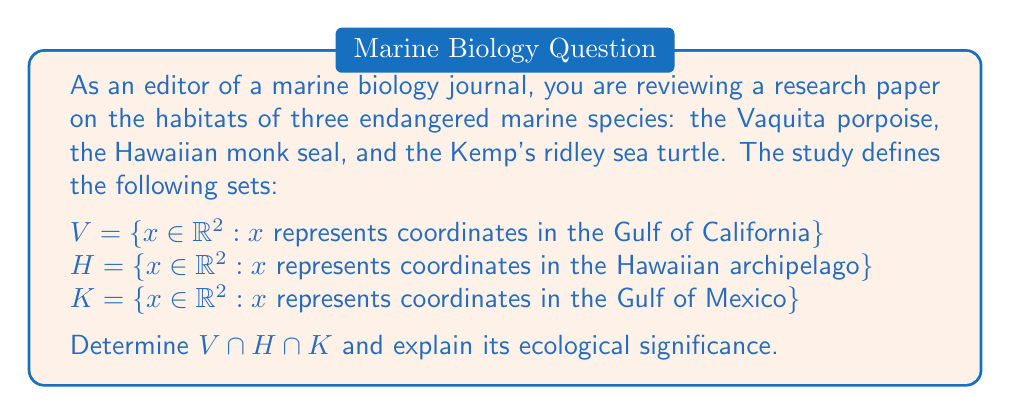Help me with this question. To solve this problem, we need to understand the concept of set intersection and apply it to the given sets representing the habitats of the three marine species.

1. Set intersection:
   The intersection of sets A and B, denoted as $A \cap B$, is the set of all elements that are common to both A and B.

2. For three sets, the intersection is defined as:
   $A \cap B \cap C = \{x : x \in A \text{ and } x \in B \text{ and } x \in C\}$

3. Analyzing the given sets:
   $V$: represents coordinates in the Gulf of California
   $H$: represents coordinates in the Hawaiian archipelago
   $K$: represents coordinates in the Gulf of Mexico

4. Geographical analysis:
   The Gulf of California, Hawaiian archipelago, and Gulf of Mexico are distinct geographical regions that do not overlap.

5. Set intersection:
   $V \cap H \cap K = \emptyset$ (the empty set)

6. Ecological significance:
   The empty intersection indicates that there is no geographical overlap in the habitats of these three endangered marine species. This implies that:
   a) Each species has a unique habitat range.
   b) Conservation efforts must be tailored to each specific location.
   c) There is no single area where protecting all three species simultaneously is possible.
   d) The species are unlikely to interact directly in their natural habitats.
Answer: $V \cap H \cap K = \emptyset$

The empty intersection signifies that the Vaquita porpoise, Hawaiian monk seal, and Kemp's ridley sea turtle have no common habitat, requiring separate conservation strategies for each species in their respective geographical areas. 